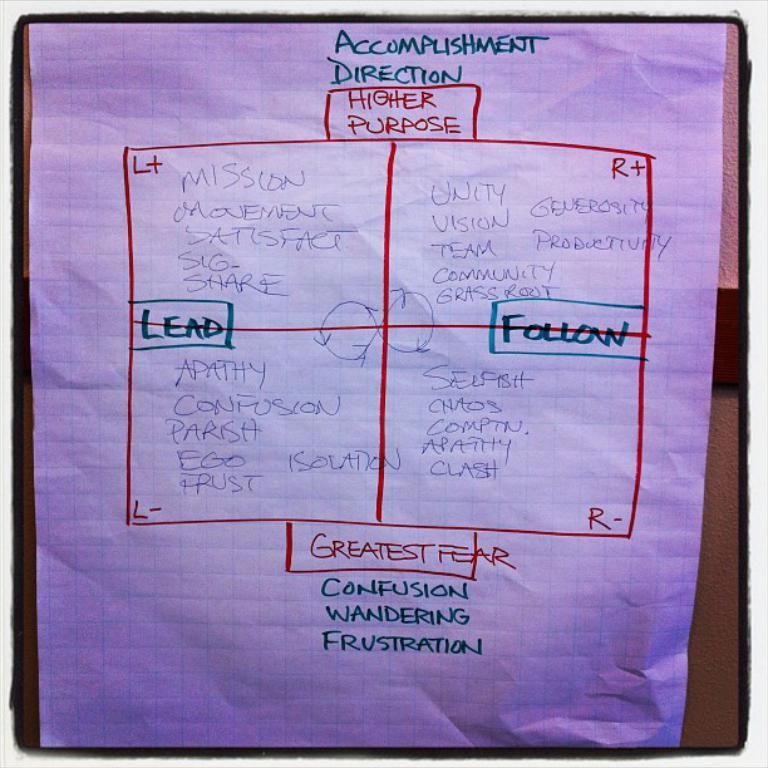<image>
Offer a succinct explanation of the picture presented. Someone has drawn a square with four quadrants organized into Lead versus Follow and Higher Purpose versus Greatest Fear. 